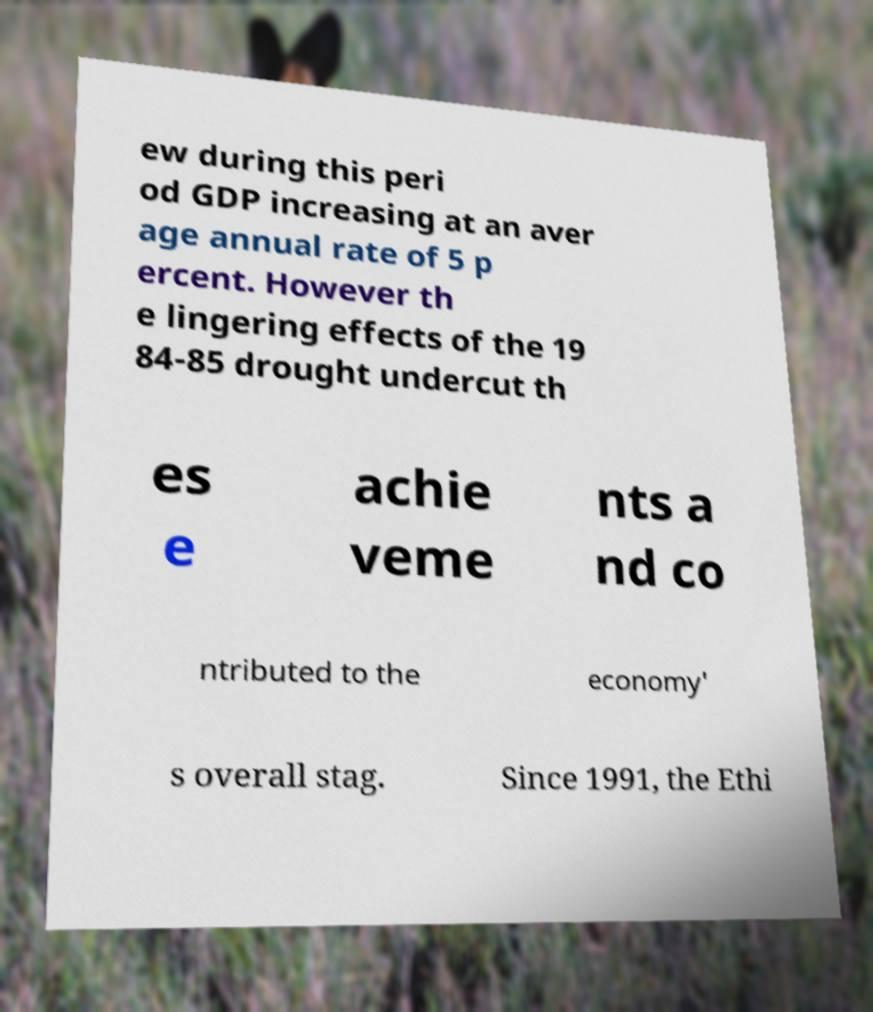There's text embedded in this image that I need extracted. Can you transcribe it verbatim? ew during this peri od GDP increasing at an aver age annual rate of 5 p ercent. However th e lingering effects of the 19 84-85 drought undercut th es e achie veme nts a nd co ntributed to the economy' s overall stag. Since 1991, the Ethi 